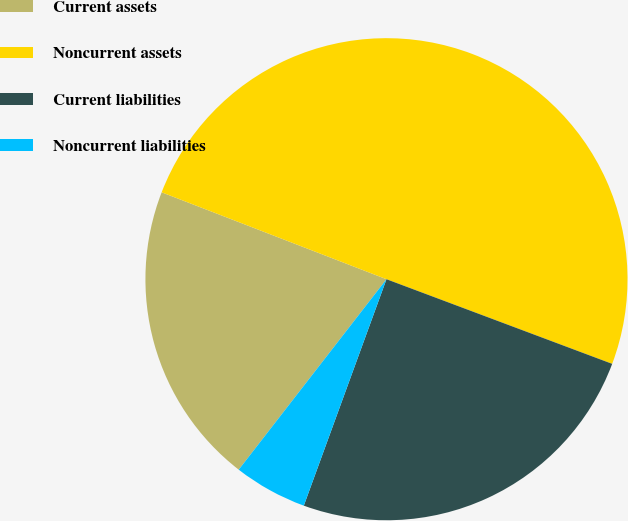Convert chart to OTSL. <chart><loc_0><loc_0><loc_500><loc_500><pie_chart><fcel>Current assets<fcel>Noncurrent assets<fcel>Current liabilities<fcel>Noncurrent liabilities<nl><fcel>20.37%<fcel>49.84%<fcel>24.86%<fcel>4.93%<nl></chart> 